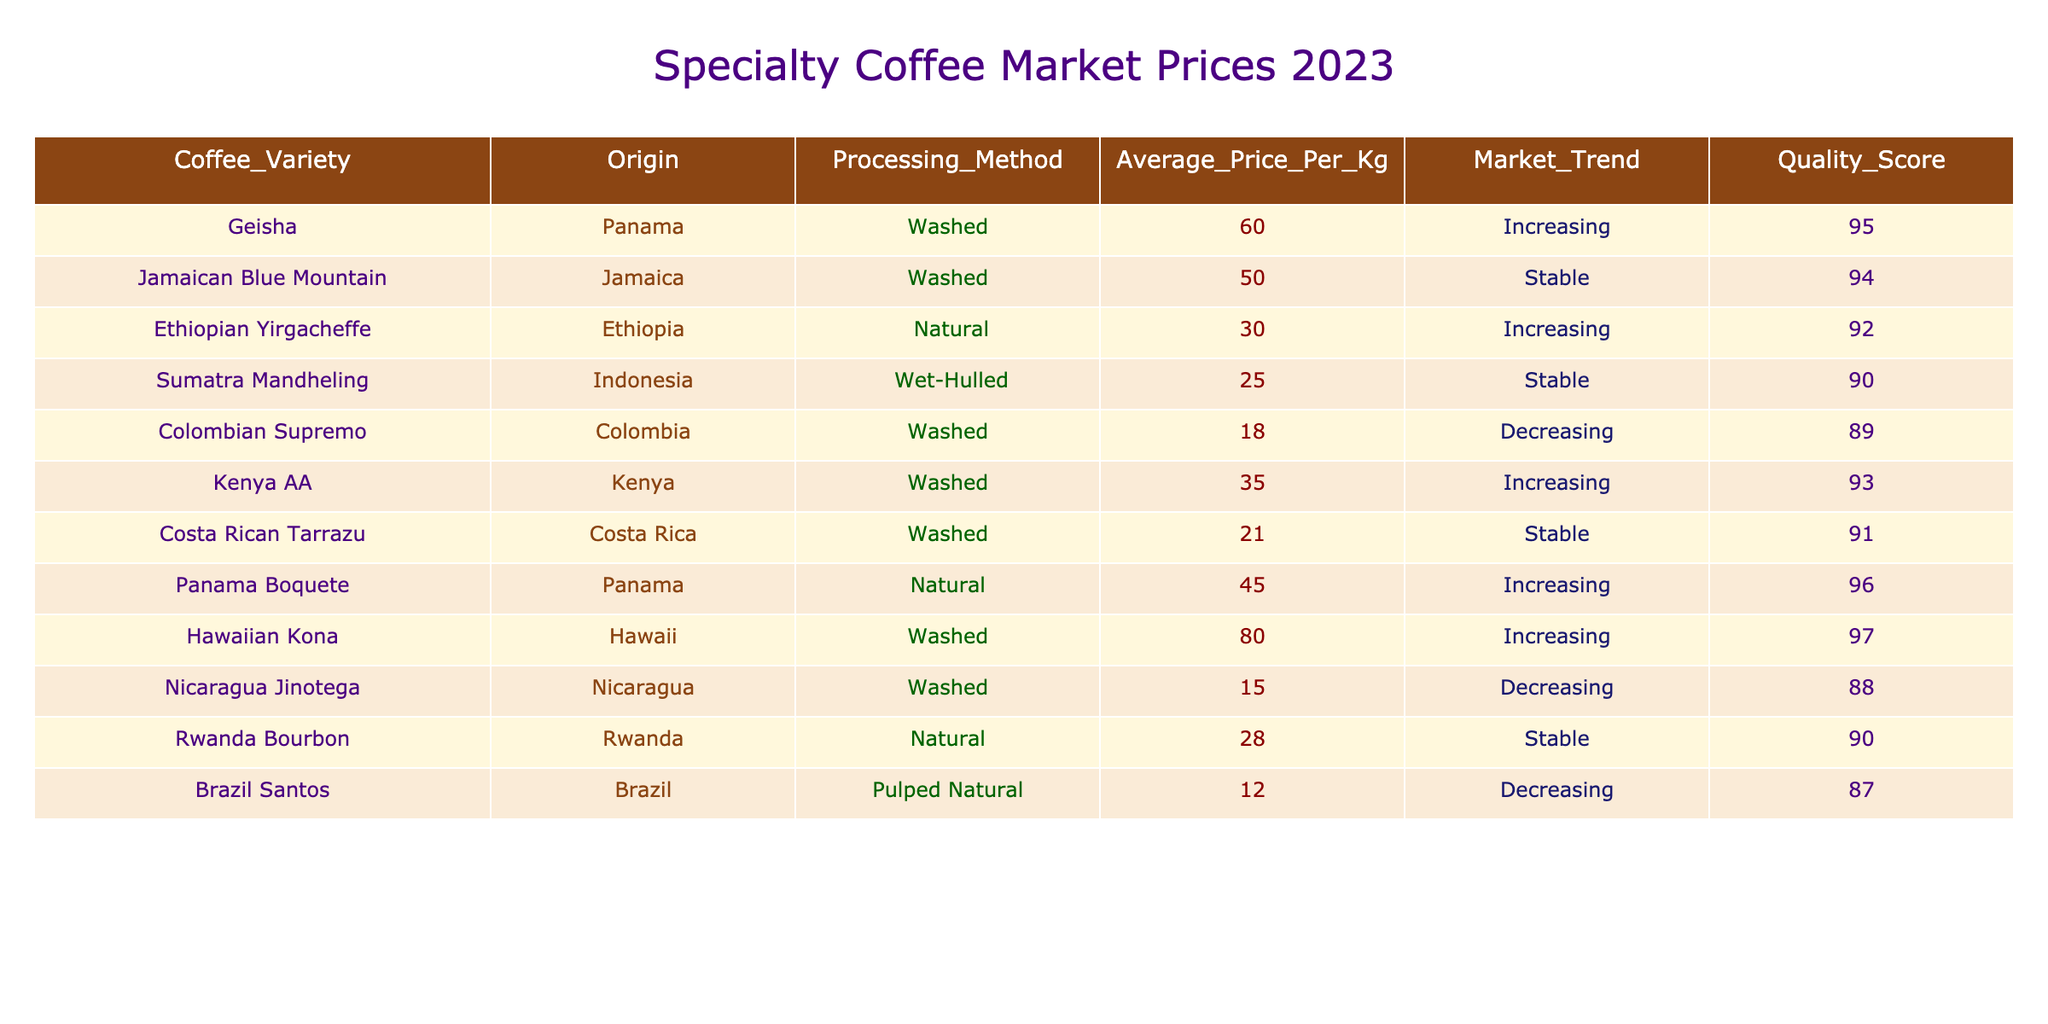What is the average price of Colombian Supremo coffee? The table lists Colombian Supremo coffee with an average price of 18.00 per kg. Therefore, the average price is simply the one stated in the table.
Answer: 18.00 Which coffee variety has the highest quality score? According to the table, Hawaiian Kona holds the highest quality score at 97, making it the top variety in this respect.
Answer: Hawaiian Kona How many coffee varieties are experiencing an increasing market trend? The table indicates that Geisha, Ethiopian Yirgacheffe, Kenya AA, Panama Boquete, Hawaiian Kona, and the others are going up in market price. Counting these varieties, there are five in total with increasing trends.
Answer: 5 Is the average price of natural-processed coffee higher than washed-processed coffee? By filtering the table, natural-processed coffees consist of Ethiopian Yirgacheffe (30.00), Rwanda Bourbon (28.00), and Panama Boquete (45.00), which average (30 + 28 + 45) / 3 = 34.33. For washed-processed, the price is (60.00 + 50.00 + 35.00 + 18.00 + 21.00 + 80.00 + 15.00) / 7 = 41.14. Since 34.33 is less than 41.14, washed has the higher average price.
Answer: No What is the difference in average price between the highest and lowest-priced coffee varieties? The highest average price is 80.00 for Hawaiian Kona, and the lowest is 12.00 for Brazil Santos. The difference is 80.00 - 12.00 = 68.00.
Answer: 68.00 